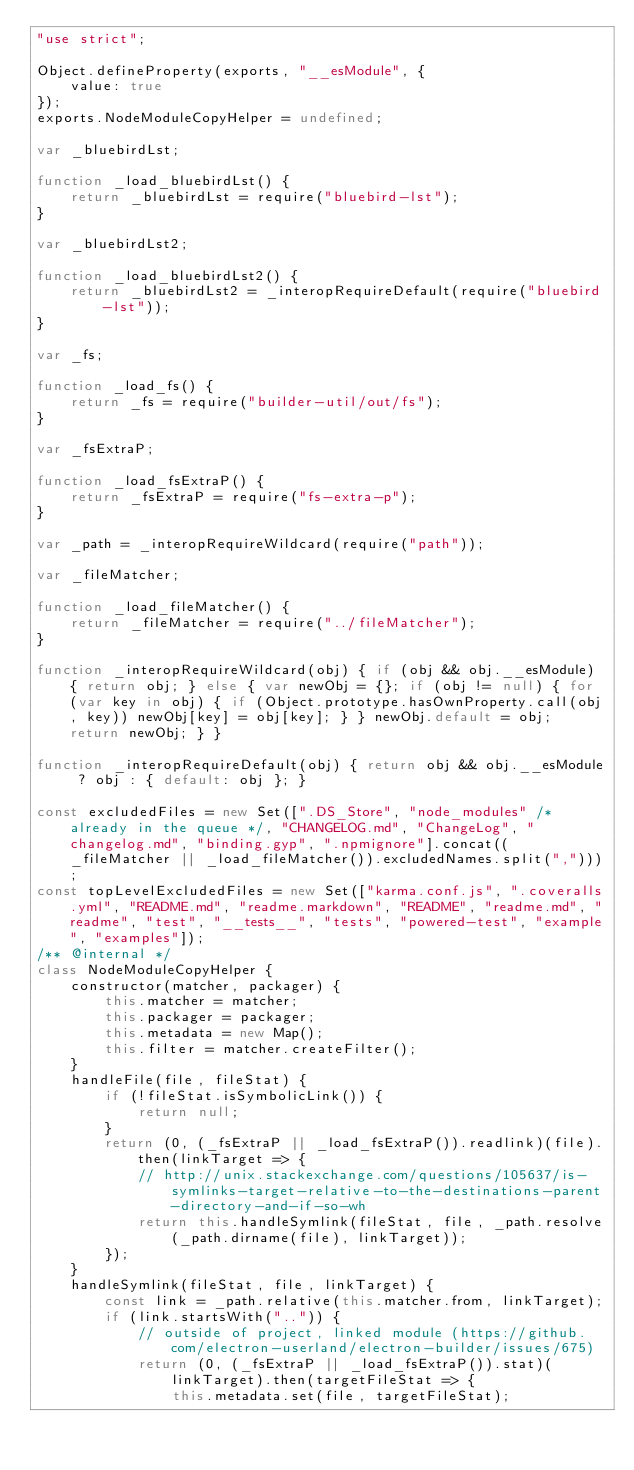<code> <loc_0><loc_0><loc_500><loc_500><_JavaScript_>"use strict";

Object.defineProperty(exports, "__esModule", {
    value: true
});
exports.NodeModuleCopyHelper = undefined;

var _bluebirdLst;

function _load_bluebirdLst() {
    return _bluebirdLst = require("bluebird-lst");
}

var _bluebirdLst2;

function _load_bluebirdLst2() {
    return _bluebirdLst2 = _interopRequireDefault(require("bluebird-lst"));
}

var _fs;

function _load_fs() {
    return _fs = require("builder-util/out/fs");
}

var _fsExtraP;

function _load_fsExtraP() {
    return _fsExtraP = require("fs-extra-p");
}

var _path = _interopRequireWildcard(require("path"));

var _fileMatcher;

function _load_fileMatcher() {
    return _fileMatcher = require("../fileMatcher");
}

function _interopRequireWildcard(obj) { if (obj && obj.__esModule) { return obj; } else { var newObj = {}; if (obj != null) { for (var key in obj) { if (Object.prototype.hasOwnProperty.call(obj, key)) newObj[key] = obj[key]; } } newObj.default = obj; return newObj; } }

function _interopRequireDefault(obj) { return obj && obj.__esModule ? obj : { default: obj }; }

const excludedFiles = new Set([".DS_Store", "node_modules" /* already in the queue */, "CHANGELOG.md", "ChangeLog", "changelog.md", "binding.gyp", ".npmignore"].concat((_fileMatcher || _load_fileMatcher()).excludedNames.split(",")));
const topLevelExcludedFiles = new Set(["karma.conf.js", ".coveralls.yml", "README.md", "readme.markdown", "README", "readme.md", "readme", "test", "__tests__", "tests", "powered-test", "example", "examples"]);
/** @internal */
class NodeModuleCopyHelper {
    constructor(matcher, packager) {
        this.matcher = matcher;
        this.packager = packager;
        this.metadata = new Map();
        this.filter = matcher.createFilter();
    }
    handleFile(file, fileStat) {
        if (!fileStat.isSymbolicLink()) {
            return null;
        }
        return (0, (_fsExtraP || _load_fsExtraP()).readlink)(file).then(linkTarget => {
            // http://unix.stackexchange.com/questions/105637/is-symlinks-target-relative-to-the-destinations-parent-directory-and-if-so-wh
            return this.handleSymlink(fileStat, file, _path.resolve(_path.dirname(file), linkTarget));
        });
    }
    handleSymlink(fileStat, file, linkTarget) {
        const link = _path.relative(this.matcher.from, linkTarget);
        if (link.startsWith("..")) {
            // outside of project, linked module (https://github.com/electron-userland/electron-builder/issues/675)
            return (0, (_fsExtraP || _load_fsExtraP()).stat)(linkTarget).then(targetFileStat => {
                this.metadata.set(file, targetFileStat);</code> 